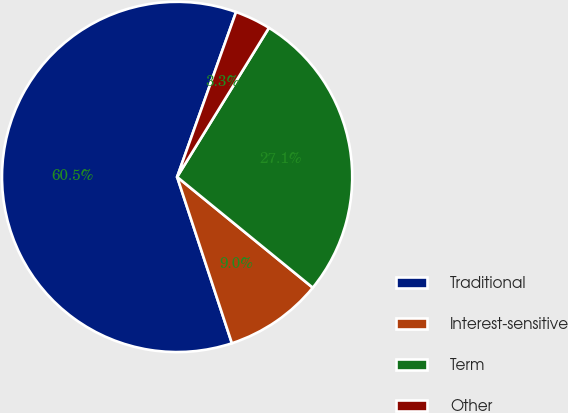Convert chart. <chart><loc_0><loc_0><loc_500><loc_500><pie_chart><fcel>Traditional<fcel>Interest-sensitive<fcel>Term<fcel>Other<nl><fcel>60.53%<fcel>9.04%<fcel>27.11%<fcel>3.32%<nl></chart> 